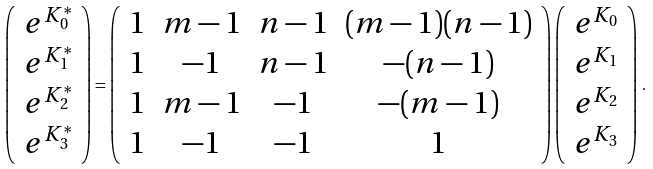Convert formula to latex. <formula><loc_0><loc_0><loc_500><loc_500>\left ( \begin{array} { c } e ^ { K ^ { * } _ { 0 } } \\ e ^ { K ^ { * } _ { 1 } } \\ e ^ { K ^ { * } _ { 2 } } \\ e ^ { K ^ { * } _ { 3 } } \\ \end{array} \right ) = \left ( \begin{array} { c c c c } 1 & m - 1 & n - 1 & ( m - 1 ) ( n - 1 ) \\ 1 & - 1 & n - 1 & - ( n - 1 ) \\ 1 & m - 1 & - 1 & - ( m - 1 ) \\ 1 & - 1 & - 1 & 1 \\ \end{array} \right ) \left ( \begin{array} { c } e ^ { K _ { 0 } } \\ e ^ { K _ { 1 } } \\ e ^ { K _ { 2 } } \\ e ^ { K _ { 3 } } \\ \end{array} \right ) \, .</formula> 